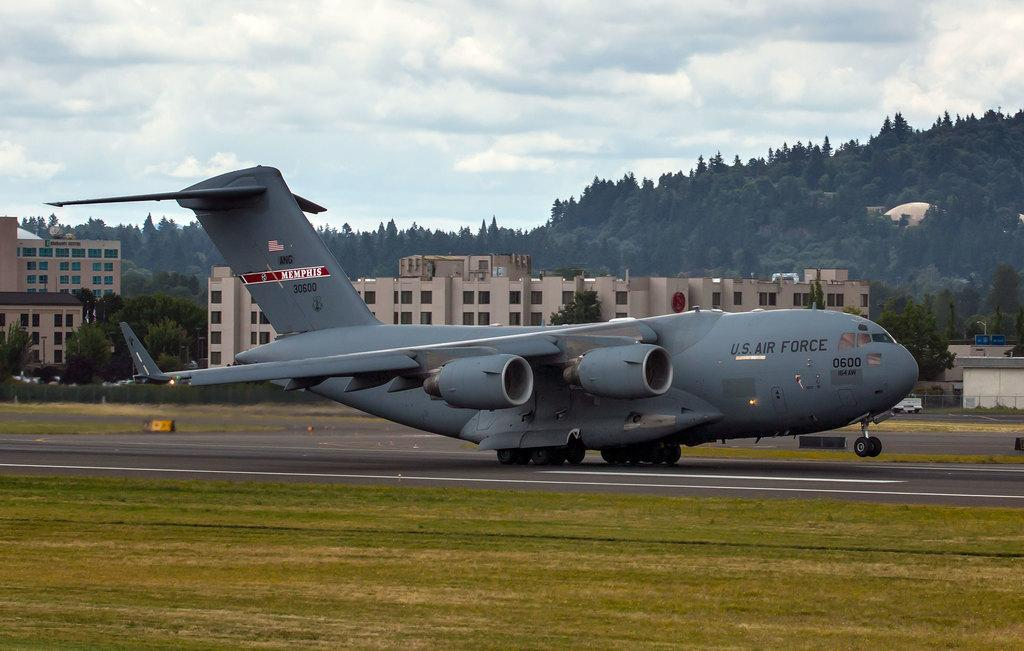<image>
Render a clear and concise summary of the photo. the words air force are on the side of a plane 